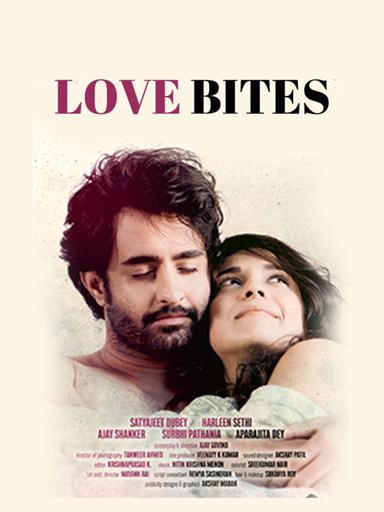What is the general mood conveyed by the 'Love Bites' movie poster? The 'Love Bites' poster conveys a tender and introspective mood, highlighted by the soft, muted color palette and the close, comfortable positioning of the actors. The facial expressions and the overall composition suggest a story of intimate, personal exploration within a romantic context. 